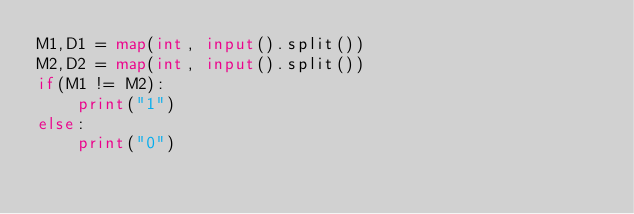Convert code to text. <code><loc_0><loc_0><loc_500><loc_500><_Python_>M1,D1 = map(int, input().split())
M2,D2 = map(int, input().split())
if(M1 != M2):
    print("1")
else:
    print("0")
</code> 